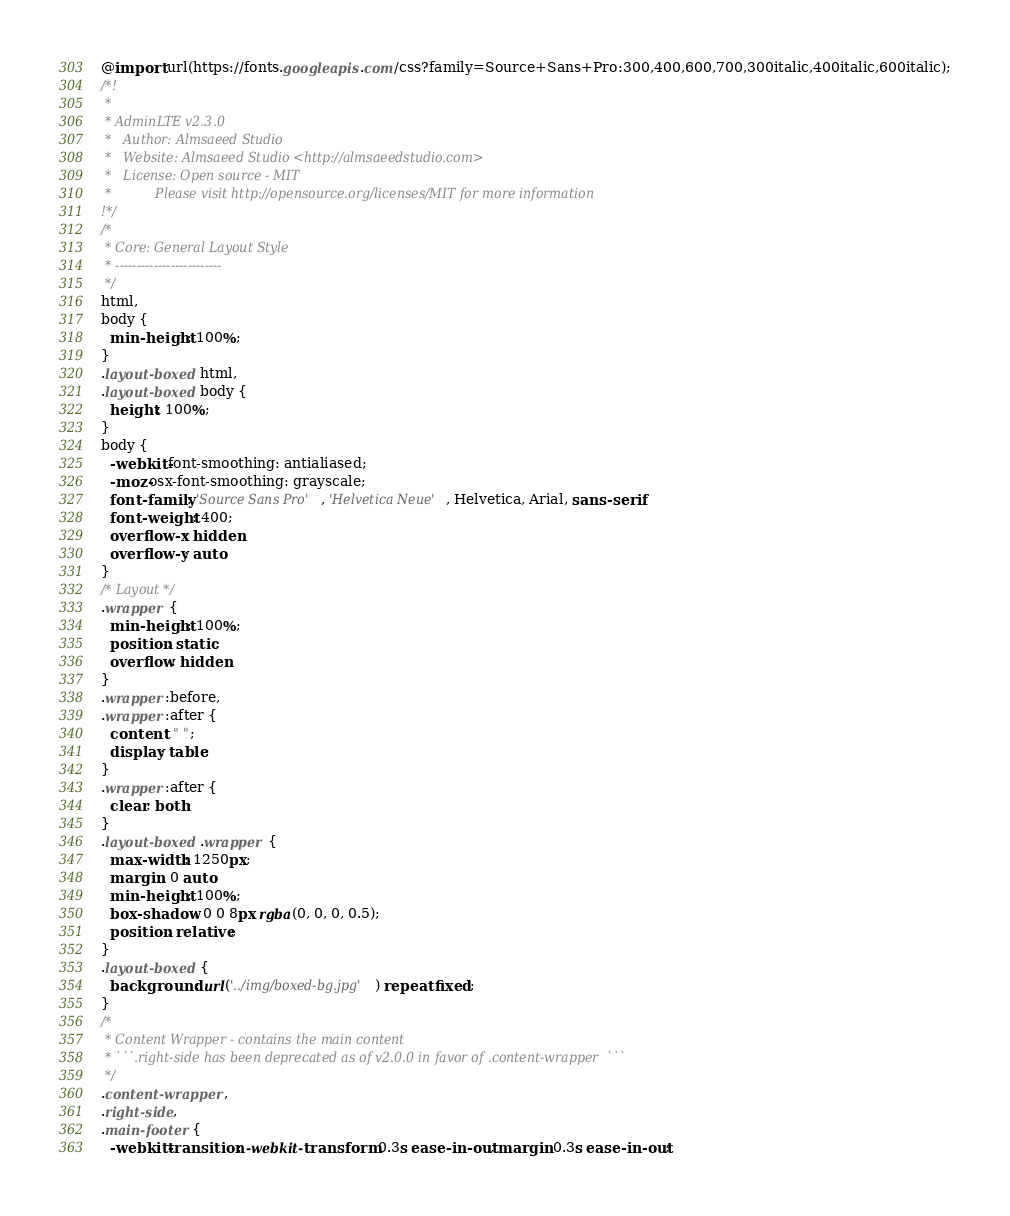Convert code to text. <code><loc_0><loc_0><loc_500><loc_500><_CSS_>@import url(https://fonts.googleapis.com/css?family=Source+Sans+Pro:300,400,600,700,300italic,400italic,600italic);
/*!
 *    
 * AdminLTE v2.3.0
 *   Author: Almsaeed Studio
 *	 Website: Almsaeed Studio <http://almsaeedstudio.com>
 *   License: Open source - MIT
 *           Please visit http://opensource.org/licenses/MIT for more information
!*/
/*
 * Core: General Layout Style
 * -------------------------
 */
html,
body {
  min-height: 100%;
}
.layout-boxed html,
.layout-boxed body {
  height: 100%;
}
body {
  -webkit-font-smoothing: antialiased;
  -moz-osx-font-smoothing: grayscale;
  font-family: 'Source Sans Pro', 'Helvetica Neue', Helvetica, Arial, sans-serif;
  font-weight: 400;
  overflow-x: hidden;
  overflow-y: auto;
}
/* Layout */
.wrapper {
  min-height: 100%;
  position: static;
  overflow: hidden;
}
.wrapper:before,
.wrapper:after {
  content: " ";
  display: table;
}
.wrapper:after {
  clear: both;
}
.layout-boxed .wrapper {
  max-width: 1250px;
  margin: 0 auto;
  min-height: 100%;
  box-shadow: 0 0 8px rgba(0, 0, 0, 0.5);
  position: relative;
}
.layout-boxed {
  background: url('../img/boxed-bg.jpg') repeat fixed;
}
/*
 * Content Wrapper - contains the main content
 * ```.right-side has been deprecated as of v2.0.0 in favor of .content-wrapper  ```
 */
.content-wrapper,
.right-side,
.main-footer {
  -webkit-transition: -webkit-transform 0.3s ease-in-out, margin 0.3s ease-in-out;</code> 